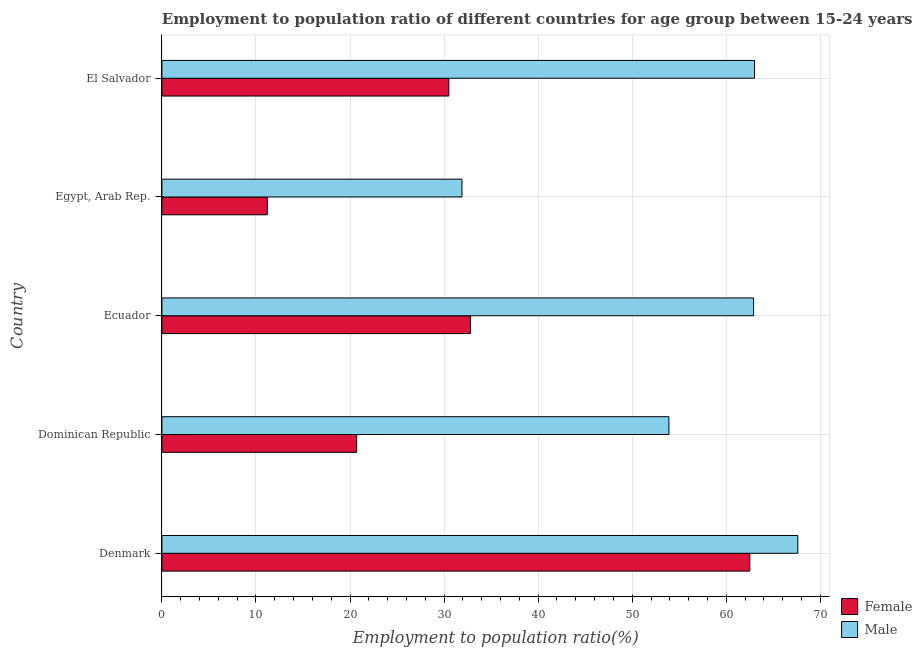How many different coloured bars are there?
Ensure brevity in your answer.  2. How many groups of bars are there?
Ensure brevity in your answer.  5. Are the number of bars per tick equal to the number of legend labels?
Your answer should be compact. Yes. How many bars are there on the 3rd tick from the bottom?
Your answer should be compact. 2. What is the label of the 4th group of bars from the top?
Offer a terse response. Dominican Republic. In how many cases, is the number of bars for a given country not equal to the number of legend labels?
Keep it short and to the point. 0. What is the employment to population ratio(female) in El Salvador?
Offer a very short reply. 30.5. Across all countries, what is the maximum employment to population ratio(female)?
Give a very brief answer. 62.5. Across all countries, what is the minimum employment to population ratio(male)?
Your answer should be compact. 31.9. In which country was the employment to population ratio(female) maximum?
Offer a terse response. Denmark. In which country was the employment to population ratio(female) minimum?
Your response must be concise. Egypt, Arab Rep. What is the total employment to population ratio(female) in the graph?
Your answer should be very brief. 157.7. What is the difference between the employment to population ratio(male) in Ecuador and the employment to population ratio(female) in El Salvador?
Provide a succinct answer. 32.4. What is the average employment to population ratio(male) per country?
Provide a short and direct response. 55.86. What is the difference between the employment to population ratio(male) and employment to population ratio(female) in Dominican Republic?
Offer a very short reply. 33.2. In how many countries, is the employment to population ratio(female) greater than 20 %?
Your answer should be compact. 4. What is the ratio of the employment to population ratio(female) in Denmark to that in El Salvador?
Make the answer very short. 2.05. Is the employment to population ratio(female) in Denmark less than that in El Salvador?
Provide a succinct answer. No. Is the difference between the employment to population ratio(male) in Denmark and Egypt, Arab Rep. greater than the difference between the employment to population ratio(female) in Denmark and Egypt, Arab Rep.?
Provide a short and direct response. No. What is the difference between the highest and the second highest employment to population ratio(female)?
Your response must be concise. 29.7. What is the difference between the highest and the lowest employment to population ratio(male)?
Keep it short and to the point. 35.7. What does the 1st bar from the top in Dominican Republic represents?
Your answer should be very brief. Male. What does the 1st bar from the bottom in Egypt, Arab Rep. represents?
Ensure brevity in your answer.  Female. How many bars are there?
Offer a terse response. 10. Are all the bars in the graph horizontal?
Give a very brief answer. Yes. Does the graph contain grids?
Your answer should be very brief. Yes. What is the title of the graph?
Keep it short and to the point. Employment to population ratio of different countries for age group between 15-24 years. Does "US$" appear as one of the legend labels in the graph?
Ensure brevity in your answer.  No. What is the Employment to population ratio(%) of Female in Denmark?
Give a very brief answer. 62.5. What is the Employment to population ratio(%) of Male in Denmark?
Keep it short and to the point. 67.6. What is the Employment to population ratio(%) of Female in Dominican Republic?
Keep it short and to the point. 20.7. What is the Employment to population ratio(%) in Male in Dominican Republic?
Keep it short and to the point. 53.9. What is the Employment to population ratio(%) of Female in Ecuador?
Provide a short and direct response. 32.8. What is the Employment to population ratio(%) of Male in Ecuador?
Your answer should be very brief. 62.9. What is the Employment to population ratio(%) of Female in Egypt, Arab Rep.?
Provide a short and direct response. 11.2. What is the Employment to population ratio(%) of Male in Egypt, Arab Rep.?
Give a very brief answer. 31.9. What is the Employment to population ratio(%) in Female in El Salvador?
Provide a short and direct response. 30.5. What is the Employment to population ratio(%) in Male in El Salvador?
Your answer should be very brief. 63. Across all countries, what is the maximum Employment to population ratio(%) in Female?
Make the answer very short. 62.5. Across all countries, what is the maximum Employment to population ratio(%) of Male?
Ensure brevity in your answer.  67.6. Across all countries, what is the minimum Employment to population ratio(%) of Female?
Provide a succinct answer. 11.2. Across all countries, what is the minimum Employment to population ratio(%) of Male?
Your answer should be compact. 31.9. What is the total Employment to population ratio(%) of Female in the graph?
Offer a very short reply. 157.7. What is the total Employment to population ratio(%) of Male in the graph?
Your answer should be very brief. 279.3. What is the difference between the Employment to population ratio(%) of Female in Denmark and that in Dominican Republic?
Give a very brief answer. 41.8. What is the difference between the Employment to population ratio(%) of Female in Denmark and that in Ecuador?
Provide a short and direct response. 29.7. What is the difference between the Employment to population ratio(%) in Female in Denmark and that in Egypt, Arab Rep.?
Make the answer very short. 51.3. What is the difference between the Employment to population ratio(%) in Male in Denmark and that in Egypt, Arab Rep.?
Your response must be concise. 35.7. What is the difference between the Employment to population ratio(%) in Male in Denmark and that in El Salvador?
Give a very brief answer. 4.6. What is the difference between the Employment to population ratio(%) of Male in Dominican Republic and that in Ecuador?
Provide a succinct answer. -9. What is the difference between the Employment to population ratio(%) of Female in Dominican Republic and that in Egypt, Arab Rep.?
Offer a very short reply. 9.5. What is the difference between the Employment to population ratio(%) in Male in Dominican Republic and that in El Salvador?
Your response must be concise. -9.1. What is the difference between the Employment to population ratio(%) of Female in Ecuador and that in Egypt, Arab Rep.?
Give a very brief answer. 21.6. What is the difference between the Employment to population ratio(%) in Male in Ecuador and that in Egypt, Arab Rep.?
Ensure brevity in your answer.  31. What is the difference between the Employment to population ratio(%) in Female in Ecuador and that in El Salvador?
Provide a short and direct response. 2.3. What is the difference between the Employment to population ratio(%) of Female in Egypt, Arab Rep. and that in El Salvador?
Offer a very short reply. -19.3. What is the difference between the Employment to population ratio(%) in Male in Egypt, Arab Rep. and that in El Salvador?
Offer a terse response. -31.1. What is the difference between the Employment to population ratio(%) of Female in Denmark and the Employment to population ratio(%) of Male in Dominican Republic?
Provide a succinct answer. 8.6. What is the difference between the Employment to population ratio(%) of Female in Denmark and the Employment to population ratio(%) of Male in Egypt, Arab Rep.?
Keep it short and to the point. 30.6. What is the difference between the Employment to population ratio(%) of Female in Denmark and the Employment to population ratio(%) of Male in El Salvador?
Give a very brief answer. -0.5. What is the difference between the Employment to population ratio(%) in Female in Dominican Republic and the Employment to population ratio(%) in Male in Ecuador?
Your response must be concise. -42.2. What is the difference between the Employment to population ratio(%) in Female in Dominican Republic and the Employment to population ratio(%) in Male in Egypt, Arab Rep.?
Provide a succinct answer. -11.2. What is the difference between the Employment to population ratio(%) in Female in Dominican Republic and the Employment to population ratio(%) in Male in El Salvador?
Ensure brevity in your answer.  -42.3. What is the difference between the Employment to population ratio(%) in Female in Ecuador and the Employment to population ratio(%) in Male in Egypt, Arab Rep.?
Your answer should be compact. 0.9. What is the difference between the Employment to population ratio(%) of Female in Ecuador and the Employment to population ratio(%) of Male in El Salvador?
Keep it short and to the point. -30.2. What is the difference between the Employment to population ratio(%) in Female in Egypt, Arab Rep. and the Employment to population ratio(%) in Male in El Salvador?
Make the answer very short. -51.8. What is the average Employment to population ratio(%) of Female per country?
Your response must be concise. 31.54. What is the average Employment to population ratio(%) of Male per country?
Provide a short and direct response. 55.86. What is the difference between the Employment to population ratio(%) of Female and Employment to population ratio(%) of Male in Dominican Republic?
Your answer should be very brief. -33.2. What is the difference between the Employment to population ratio(%) of Female and Employment to population ratio(%) of Male in Ecuador?
Offer a terse response. -30.1. What is the difference between the Employment to population ratio(%) of Female and Employment to population ratio(%) of Male in Egypt, Arab Rep.?
Provide a short and direct response. -20.7. What is the difference between the Employment to population ratio(%) in Female and Employment to population ratio(%) in Male in El Salvador?
Give a very brief answer. -32.5. What is the ratio of the Employment to population ratio(%) in Female in Denmark to that in Dominican Republic?
Give a very brief answer. 3.02. What is the ratio of the Employment to population ratio(%) of Male in Denmark to that in Dominican Republic?
Your answer should be compact. 1.25. What is the ratio of the Employment to population ratio(%) in Female in Denmark to that in Ecuador?
Keep it short and to the point. 1.91. What is the ratio of the Employment to population ratio(%) of Male in Denmark to that in Ecuador?
Offer a very short reply. 1.07. What is the ratio of the Employment to population ratio(%) in Female in Denmark to that in Egypt, Arab Rep.?
Provide a short and direct response. 5.58. What is the ratio of the Employment to population ratio(%) in Male in Denmark to that in Egypt, Arab Rep.?
Your response must be concise. 2.12. What is the ratio of the Employment to population ratio(%) of Female in Denmark to that in El Salvador?
Provide a short and direct response. 2.05. What is the ratio of the Employment to population ratio(%) in Male in Denmark to that in El Salvador?
Your answer should be very brief. 1.07. What is the ratio of the Employment to population ratio(%) in Female in Dominican Republic to that in Ecuador?
Your answer should be compact. 0.63. What is the ratio of the Employment to population ratio(%) in Male in Dominican Republic to that in Ecuador?
Your answer should be very brief. 0.86. What is the ratio of the Employment to population ratio(%) in Female in Dominican Republic to that in Egypt, Arab Rep.?
Your answer should be compact. 1.85. What is the ratio of the Employment to population ratio(%) of Male in Dominican Republic to that in Egypt, Arab Rep.?
Your answer should be compact. 1.69. What is the ratio of the Employment to population ratio(%) in Female in Dominican Republic to that in El Salvador?
Offer a very short reply. 0.68. What is the ratio of the Employment to population ratio(%) of Male in Dominican Republic to that in El Salvador?
Give a very brief answer. 0.86. What is the ratio of the Employment to population ratio(%) of Female in Ecuador to that in Egypt, Arab Rep.?
Your response must be concise. 2.93. What is the ratio of the Employment to population ratio(%) of Male in Ecuador to that in Egypt, Arab Rep.?
Provide a succinct answer. 1.97. What is the ratio of the Employment to population ratio(%) in Female in Ecuador to that in El Salvador?
Provide a short and direct response. 1.08. What is the ratio of the Employment to population ratio(%) in Male in Ecuador to that in El Salvador?
Provide a short and direct response. 1. What is the ratio of the Employment to population ratio(%) in Female in Egypt, Arab Rep. to that in El Salvador?
Offer a terse response. 0.37. What is the ratio of the Employment to population ratio(%) of Male in Egypt, Arab Rep. to that in El Salvador?
Give a very brief answer. 0.51. What is the difference between the highest and the second highest Employment to population ratio(%) in Female?
Your answer should be very brief. 29.7. What is the difference between the highest and the lowest Employment to population ratio(%) in Female?
Keep it short and to the point. 51.3. What is the difference between the highest and the lowest Employment to population ratio(%) in Male?
Your response must be concise. 35.7. 